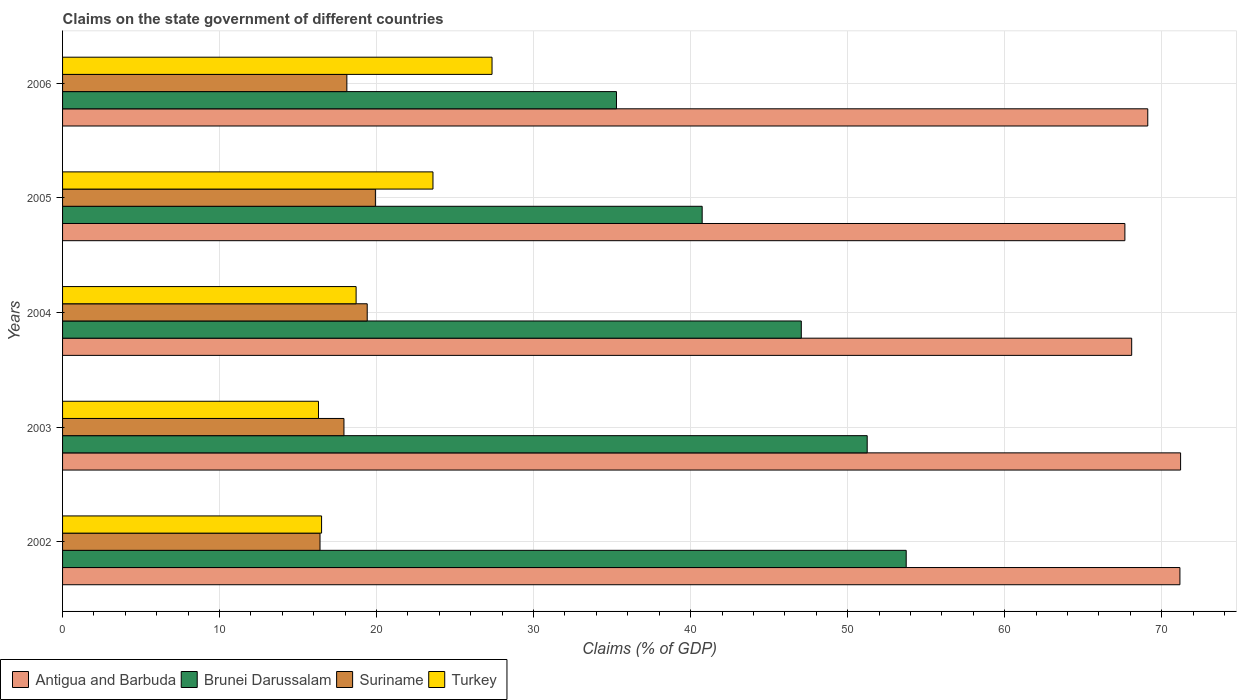How many groups of bars are there?
Make the answer very short. 5. Are the number of bars per tick equal to the number of legend labels?
Ensure brevity in your answer.  Yes. Are the number of bars on each tick of the Y-axis equal?
Offer a terse response. Yes. How many bars are there on the 5th tick from the bottom?
Provide a short and direct response. 4. What is the label of the 2nd group of bars from the top?
Ensure brevity in your answer.  2005. In how many cases, is the number of bars for a given year not equal to the number of legend labels?
Offer a very short reply. 0. What is the percentage of GDP claimed on the state government in Suriname in 2005?
Ensure brevity in your answer.  19.92. Across all years, what is the maximum percentage of GDP claimed on the state government in Antigua and Barbuda?
Keep it short and to the point. 71.21. Across all years, what is the minimum percentage of GDP claimed on the state government in Antigua and Barbuda?
Give a very brief answer. 67.66. In which year was the percentage of GDP claimed on the state government in Suriname minimum?
Your response must be concise. 2002. What is the total percentage of GDP claimed on the state government in Antigua and Barbuda in the graph?
Ensure brevity in your answer.  347.25. What is the difference between the percentage of GDP claimed on the state government in Suriname in 2002 and that in 2005?
Provide a succinct answer. -3.53. What is the difference between the percentage of GDP claimed on the state government in Brunei Darussalam in 2004 and the percentage of GDP claimed on the state government in Antigua and Barbuda in 2006?
Keep it short and to the point. -22.07. What is the average percentage of GDP claimed on the state government in Suriname per year?
Ensure brevity in your answer.  18.35. In the year 2003, what is the difference between the percentage of GDP claimed on the state government in Brunei Darussalam and percentage of GDP claimed on the state government in Suriname?
Give a very brief answer. 33.33. In how many years, is the percentage of GDP claimed on the state government in Suriname greater than 28 %?
Your answer should be compact. 0. What is the ratio of the percentage of GDP claimed on the state government in Turkey in 2003 to that in 2004?
Give a very brief answer. 0.87. Is the percentage of GDP claimed on the state government in Brunei Darussalam in 2004 less than that in 2006?
Offer a very short reply. No. What is the difference between the highest and the second highest percentage of GDP claimed on the state government in Turkey?
Your response must be concise. 3.76. What is the difference between the highest and the lowest percentage of GDP claimed on the state government in Antigua and Barbuda?
Ensure brevity in your answer.  3.55. In how many years, is the percentage of GDP claimed on the state government in Antigua and Barbuda greater than the average percentage of GDP claimed on the state government in Antigua and Barbuda taken over all years?
Your response must be concise. 2. Is it the case that in every year, the sum of the percentage of GDP claimed on the state government in Antigua and Barbuda and percentage of GDP claimed on the state government in Turkey is greater than the sum of percentage of GDP claimed on the state government in Suriname and percentage of GDP claimed on the state government in Brunei Darussalam?
Your answer should be very brief. Yes. What does the 4th bar from the top in 2003 represents?
Provide a short and direct response. Antigua and Barbuda. What does the 1st bar from the bottom in 2005 represents?
Ensure brevity in your answer.  Antigua and Barbuda. Is it the case that in every year, the sum of the percentage of GDP claimed on the state government in Suriname and percentage of GDP claimed on the state government in Brunei Darussalam is greater than the percentage of GDP claimed on the state government in Antigua and Barbuda?
Your response must be concise. No. How many bars are there?
Make the answer very short. 20. Are all the bars in the graph horizontal?
Give a very brief answer. Yes. Are the values on the major ticks of X-axis written in scientific E-notation?
Make the answer very short. No. Does the graph contain any zero values?
Offer a very short reply. No. Does the graph contain grids?
Give a very brief answer. Yes. Where does the legend appear in the graph?
Keep it short and to the point. Bottom left. How many legend labels are there?
Give a very brief answer. 4. What is the title of the graph?
Ensure brevity in your answer.  Claims on the state government of different countries. Does "East Asia (all income levels)" appear as one of the legend labels in the graph?
Make the answer very short. No. What is the label or title of the X-axis?
Your answer should be very brief. Claims (% of GDP). What is the label or title of the Y-axis?
Provide a succinct answer. Years. What is the Claims (% of GDP) of Antigua and Barbuda in 2002?
Your answer should be compact. 71.17. What is the Claims (% of GDP) in Brunei Darussalam in 2002?
Your answer should be compact. 53.73. What is the Claims (% of GDP) in Suriname in 2002?
Offer a very short reply. 16.4. What is the Claims (% of GDP) of Turkey in 2002?
Offer a terse response. 16.5. What is the Claims (% of GDP) in Antigua and Barbuda in 2003?
Offer a terse response. 71.21. What is the Claims (% of GDP) of Brunei Darussalam in 2003?
Give a very brief answer. 51.25. What is the Claims (% of GDP) of Suriname in 2003?
Make the answer very short. 17.92. What is the Claims (% of GDP) in Turkey in 2003?
Give a very brief answer. 16.3. What is the Claims (% of GDP) of Antigua and Barbuda in 2004?
Offer a terse response. 68.09. What is the Claims (% of GDP) of Brunei Darussalam in 2004?
Offer a terse response. 47.05. What is the Claims (% of GDP) of Suriname in 2004?
Offer a very short reply. 19.4. What is the Claims (% of GDP) of Turkey in 2004?
Offer a very short reply. 18.7. What is the Claims (% of GDP) in Antigua and Barbuda in 2005?
Provide a short and direct response. 67.66. What is the Claims (% of GDP) of Brunei Darussalam in 2005?
Keep it short and to the point. 40.74. What is the Claims (% of GDP) of Suriname in 2005?
Ensure brevity in your answer.  19.92. What is the Claims (% of GDP) of Turkey in 2005?
Keep it short and to the point. 23.59. What is the Claims (% of GDP) of Antigua and Barbuda in 2006?
Offer a very short reply. 69.12. What is the Claims (% of GDP) in Brunei Darussalam in 2006?
Keep it short and to the point. 35.28. What is the Claims (% of GDP) in Suriname in 2006?
Provide a succinct answer. 18.11. What is the Claims (% of GDP) of Turkey in 2006?
Give a very brief answer. 27.35. Across all years, what is the maximum Claims (% of GDP) of Antigua and Barbuda?
Ensure brevity in your answer.  71.21. Across all years, what is the maximum Claims (% of GDP) in Brunei Darussalam?
Make the answer very short. 53.73. Across all years, what is the maximum Claims (% of GDP) in Suriname?
Provide a succinct answer. 19.92. Across all years, what is the maximum Claims (% of GDP) in Turkey?
Ensure brevity in your answer.  27.35. Across all years, what is the minimum Claims (% of GDP) in Antigua and Barbuda?
Your answer should be compact. 67.66. Across all years, what is the minimum Claims (% of GDP) of Brunei Darussalam?
Provide a succinct answer. 35.28. Across all years, what is the minimum Claims (% of GDP) in Suriname?
Your answer should be very brief. 16.4. Across all years, what is the minimum Claims (% of GDP) of Turkey?
Your response must be concise. 16.3. What is the total Claims (% of GDP) in Antigua and Barbuda in the graph?
Offer a very short reply. 347.25. What is the total Claims (% of GDP) of Brunei Darussalam in the graph?
Provide a short and direct response. 228.05. What is the total Claims (% of GDP) in Suriname in the graph?
Provide a short and direct response. 91.76. What is the total Claims (% of GDP) in Turkey in the graph?
Keep it short and to the point. 102.44. What is the difference between the Claims (% of GDP) in Antigua and Barbuda in 2002 and that in 2003?
Offer a terse response. -0.04. What is the difference between the Claims (% of GDP) of Brunei Darussalam in 2002 and that in 2003?
Your answer should be very brief. 2.48. What is the difference between the Claims (% of GDP) of Suriname in 2002 and that in 2003?
Offer a terse response. -1.52. What is the difference between the Claims (% of GDP) in Turkey in 2002 and that in 2003?
Your response must be concise. 0.2. What is the difference between the Claims (% of GDP) in Antigua and Barbuda in 2002 and that in 2004?
Keep it short and to the point. 3.07. What is the difference between the Claims (% of GDP) in Brunei Darussalam in 2002 and that in 2004?
Provide a succinct answer. 6.68. What is the difference between the Claims (% of GDP) in Suriname in 2002 and that in 2004?
Offer a very short reply. -3.01. What is the difference between the Claims (% of GDP) in Turkey in 2002 and that in 2004?
Give a very brief answer. -2.2. What is the difference between the Claims (% of GDP) in Antigua and Barbuda in 2002 and that in 2005?
Your answer should be very brief. 3.5. What is the difference between the Claims (% of GDP) of Brunei Darussalam in 2002 and that in 2005?
Give a very brief answer. 13. What is the difference between the Claims (% of GDP) of Suriname in 2002 and that in 2005?
Your answer should be compact. -3.53. What is the difference between the Claims (% of GDP) in Turkey in 2002 and that in 2005?
Offer a terse response. -7.09. What is the difference between the Claims (% of GDP) of Antigua and Barbuda in 2002 and that in 2006?
Make the answer very short. 2.05. What is the difference between the Claims (% of GDP) in Brunei Darussalam in 2002 and that in 2006?
Make the answer very short. 18.45. What is the difference between the Claims (% of GDP) in Suriname in 2002 and that in 2006?
Provide a short and direct response. -1.71. What is the difference between the Claims (% of GDP) of Turkey in 2002 and that in 2006?
Make the answer very short. -10.86. What is the difference between the Claims (% of GDP) in Antigua and Barbuda in 2003 and that in 2004?
Your answer should be very brief. 3.11. What is the difference between the Claims (% of GDP) in Brunei Darussalam in 2003 and that in 2004?
Provide a short and direct response. 4.2. What is the difference between the Claims (% of GDP) in Suriname in 2003 and that in 2004?
Ensure brevity in your answer.  -1.48. What is the difference between the Claims (% of GDP) in Turkey in 2003 and that in 2004?
Provide a short and direct response. -2.4. What is the difference between the Claims (% of GDP) in Antigua and Barbuda in 2003 and that in 2005?
Make the answer very short. 3.55. What is the difference between the Claims (% of GDP) of Brunei Darussalam in 2003 and that in 2005?
Your answer should be compact. 10.51. What is the difference between the Claims (% of GDP) of Suriname in 2003 and that in 2005?
Your response must be concise. -2. What is the difference between the Claims (% of GDP) of Turkey in 2003 and that in 2005?
Provide a short and direct response. -7.29. What is the difference between the Claims (% of GDP) of Antigua and Barbuda in 2003 and that in 2006?
Ensure brevity in your answer.  2.09. What is the difference between the Claims (% of GDP) in Brunei Darussalam in 2003 and that in 2006?
Ensure brevity in your answer.  15.97. What is the difference between the Claims (% of GDP) of Suriname in 2003 and that in 2006?
Provide a succinct answer. -0.19. What is the difference between the Claims (% of GDP) of Turkey in 2003 and that in 2006?
Provide a short and direct response. -11.05. What is the difference between the Claims (% of GDP) in Antigua and Barbuda in 2004 and that in 2005?
Your answer should be compact. 0.43. What is the difference between the Claims (% of GDP) in Brunei Darussalam in 2004 and that in 2005?
Offer a terse response. 6.31. What is the difference between the Claims (% of GDP) in Suriname in 2004 and that in 2005?
Your response must be concise. -0.52. What is the difference between the Claims (% of GDP) of Turkey in 2004 and that in 2005?
Offer a terse response. -4.89. What is the difference between the Claims (% of GDP) in Antigua and Barbuda in 2004 and that in 2006?
Ensure brevity in your answer.  -1.02. What is the difference between the Claims (% of GDP) of Brunei Darussalam in 2004 and that in 2006?
Your answer should be compact. 11.77. What is the difference between the Claims (% of GDP) in Suriname in 2004 and that in 2006?
Offer a very short reply. 1.3. What is the difference between the Claims (% of GDP) of Turkey in 2004 and that in 2006?
Your answer should be very brief. -8.66. What is the difference between the Claims (% of GDP) of Antigua and Barbuda in 2005 and that in 2006?
Offer a terse response. -1.46. What is the difference between the Claims (% of GDP) of Brunei Darussalam in 2005 and that in 2006?
Make the answer very short. 5.46. What is the difference between the Claims (% of GDP) of Suriname in 2005 and that in 2006?
Make the answer very short. 1.82. What is the difference between the Claims (% of GDP) of Turkey in 2005 and that in 2006?
Keep it short and to the point. -3.76. What is the difference between the Claims (% of GDP) of Antigua and Barbuda in 2002 and the Claims (% of GDP) of Brunei Darussalam in 2003?
Ensure brevity in your answer.  19.92. What is the difference between the Claims (% of GDP) of Antigua and Barbuda in 2002 and the Claims (% of GDP) of Suriname in 2003?
Keep it short and to the point. 53.24. What is the difference between the Claims (% of GDP) of Antigua and Barbuda in 2002 and the Claims (% of GDP) of Turkey in 2003?
Offer a terse response. 54.87. What is the difference between the Claims (% of GDP) in Brunei Darussalam in 2002 and the Claims (% of GDP) in Suriname in 2003?
Your response must be concise. 35.81. What is the difference between the Claims (% of GDP) in Brunei Darussalam in 2002 and the Claims (% of GDP) in Turkey in 2003?
Provide a short and direct response. 37.43. What is the difference between the Claims (% of GDP) of Suriname in 2002 and the Claims (% of GDP) of Turkey in 2003?
Offer a terse response. 0.1. What is the difference between the Claims (% of GDP) of Antigua and Barbuda in 2002 and the Claims (% of GDP) of Brunei Darussalam in 2004?
Offer a terse response. 24.11. What is the difference between the Claims (% of GDP) in Antigua and Barbuda in 2002 and the Claims (% of GDP) in Suriname in 2004?
Keep it short and to the point. 51.76. What is the difference between the Claims (% of GDP) of Antigua and Barbuda in 2002 and the Claims (% of GDP) of Turkey in 2004?
Provide a short and direct response. 52.47. What is the difference between the Claims (% of GDP) of Brunei Darussalam in 2002 and the Claims (% of GDP) of Suriname in 2004?
Ensure brevity in your answer.  34.33. What is the difference between the Claims (% of GDP) in Brunei Darussalam in 2002 and the Claims (% of GDP) in Turkey in 2004?
Offer a very short reply. 35.04. What is the difference between the Claims (% of GDP) of Suriname in 2002 and the Claims (% of GDP) of Turkey in 2004?
Your answer should be compact. -2.3. What is the difference between the Claims (% of GDP) of Antigua and Barbuda in 2002 and the Claims (% of GDP) of Brunei Darussalam in 2005?
Provide a succinct answer. 30.43. What is the difference between the Claims (% of GDP) in Antigua and Barbuda in 2002 and the Claims (% of GDP) in Suriname in 2005?
Provide a short and direct response. 51.24. What is the difference between the Claims (% of GDP) of Antigua and Barbuda in 2002 and the Claims (% of GDP) of Turkey in 2005?
Keep it short and to the point. 47.57. What is the difference between the Claims (% of GDP) in Brunei Darussalam in 2002 and the Claims (% of GDP) in Suriname in 2005?
Give a very brief answer. 33.81. What is the difference between the Claims (% of GDP) of Brunei Darussalam in 2002 and the Claims (% of GDP) of Turkey in 2005?
Ensure brevity in your answer.  30.14. What is the difference between the Claims (% of GDP) of Suriname in 2002 and the Claims (% of GDP) of Turkey in 2005?
Make the answer very short. -7.19. What is the difference between the Claims (% of GDP) in Antigua and Barbuda in 2002 and the Claims (% of GDP) in Brunei Darussalam in 2006?
Make the answer very short. 35.89. What is the difference between the Claims (% of GDP) of Antigua and Barbuda in 2002 and the Claims (% of GDP) of Suriname in 2006?
Your answer should be compact. 53.06. What is the difference between the Claims (% of GDP) in Antigua and Barbuda in 2002 and the Claims (% of GDP) in Turkey in 2006?
Keep it short and to the point. 43.81. What is the difference between the Claims (% of GDP) of Brunei Darussalam in 2002 and the Claims (% of GDP) of Suriname in 2006?
Keep it short and to the point. 35.63. What is the difference between the Claims (% of GDP) in Brunei Darussalam in 2002 and the Claims (% of GDP) in Turkey in 2006?
Make the answer very short. 26.38. What is the difference between the Claims (% of GDP) of Suriname in 2002 and the Claims (% of GDP) of Turkey in 2006?
Your answer should be very brief. -10.96. What is the difference between the Claims (% of GDP) in Antigua and Barbuda in 2003 and the Claims (% of GDP) in Brunei Darussalam in 2004?
Ensure brevity in your answer.  24.16. What is the difference between the Claims (% of GDP) in Antigua and Barbuda in 2003 and the Claims (% of GDP) in Suriname in 2004?
Make the answer very short. 51.8. What is the difference between the Claims (% of GDP) in Antigua and Barbuda in 2003 and the Claims (% of GDP) in Turkey in 2004?
Provide a short and direct response. 52.51. What is the difference between the Claims (% of GDP) in Brunei Darussalam in 2003 and the Claims (% of GDP) in Suriname in 2004?
Offer a terse response. 31.84. What is the difference between the Claims (% of GDP) of Brunei Darussalam in 2003 and the Claims (% of GDP) of Turkey in 2004?
Give a very brief answer. 32.55. What is the difference between the Claims (% of GDP) in Suriname in 2003 and the Claims (% of GDP) in Turkey in 2004?
Your response must be concise. -0.77. What is the difference between the Claims (% of GDP) of Antigua and Barbuda in 2003 and the Claims (% of GDP) of Brunei Darussalam in 2005?
Your answer should be very brief. 30.47. What is the difference between the Claims (% of GDP) of Antigua and Barbuda in 2003 and the Claims (% of GDP) of Suriname in 2005?
Keep it short and to the point. 51.28. What is the difference between the Claims (% of GDP) in Antigua and Barbuda in 2003 and the Claims (% of GDP) in Turkey in 2005?
Your response must be concise. 47.62. What is the difference between the Claims (% of GDP) of Brunei Darussalam in 2003 and the Claims (% of GDP) of Suriname in 2005?
Give a very brief answer. 31.32. What is the difference between the Claims (% of GDP) of Brunei Darussalam in 2003 and the Claims (% of GDP) of Turkey in 2005?
Keep it short and to the point. 27.66. What is the difference between the Claims (% of GDP) of Suriname in 2003 and the Claims (% of GDP) of Turkey in 2005?
Provide a succinct answer. -5.67. What is the difference between the Claims (% of GDP) in Antigua and Barbuda in 2003 and the Claims (% of GDP) in Brunei Darussalam in 2006?
Offer a terse response. 35.93. What is the difference between the Claims (% of GDP) in Antigua and Barbuda in 2003 and the Claims (% of GDP) in Suriname in 2006?
Offer a very short reply. 53.1. What is the difference between the Claims (% of GDP) in Antigua and Barbuda in 2003 and the Claims (% of GDP) in Turkey in 2006?
Your answer should be very brief. 43.86. What is the difference between the Claims (% of GDP) of Brunei Darussalam in 2003 and the Claims (% of GDP) of Suriname in 2006?
Your answer should be compact. 33.14. What is the difference between the Claims (% of GDP) of Brunei Darussalam in 2003 and the Claims (% of GDP) of Turkey in 2006?
Keep it short and to the point. 23.9. What is the difference between the Claims (% of GDP) in Suriname in 2003 and the Claims (% of GDP) in Turkey in 2006?
Your response must be concise. -9.43. What is the difference between the Claims (% of GDP) in Antigua and Barbuda in 2004 and the Claims (% of GDP) in Brunei Darussalam in 2005?
Your answer should be very brief. 27.36. What is the difference between the Claims (% of GDP) in Antigua and Barbuda in 2004 and the Claims (% of GDP) in Suriname in 2005?
Make the answer very short. 48.17. What is the difference between the Claims (% of GDP) of Antigua and Barbuda in 2004 and the Claims (% of GDP) of Turkey in 2005?
Make the answer very short. 44.5. What is the difference between the Claims (% of GDP) in Brunei Darussalam in 2004 and the Claims (% of GDP) in Suriname in 2005?
Make the answer very short. 27.13. What is the difference between the Claims (% of GDP) in Brunei Darussalam in 2004 and the Claims (% of GDP) in Turkey in 2005?
Your answer should be compact. 23.46. What is the difference between the Claims (% of GDP) of Suriname in 2004 and the Claims (% of GDP) of Turkey in 2005?
Ensure brevity in your answer.  -4.19. What is the difference between the Claims (% of GDP) in Antigua and Barbuda in 2004 and the Claims (% of GDP) in Brunei Darussalam in 2006?
Keep it short and to the point. 32.82. What is the difference between the Claims (% of GDP) in Antigua and Barbuda in 2004 and the Claims (% of GDP) in Suriname in 2006?
Ensure brevity in your answer.  49.99. What is the difference between the Claims (% of GDP) in Antigua and Barbuda in 2004 and the Claims (% of GDP) in Turkey in 2006?
Offer a very short reply. 40.74. What is the difference between the Claims (% of GDP) in Brunei Darussalam in 2004 and the Claims (% of GDP) in Suriname in 2006?
Give a very brief answer. 28.94. What is the difference between the Claims (% of GDP) in Brunei Darussalam in 2004 and the Claims (% of GDP) in Turkey in 2006?
Your response must be concise. 19.7. What is the difference between the Claims (% of GDP) in Suriname in 2004 and the Claims (% of GDP) in Turkey in 2006?
Make the answer very short. -7.95. What is the difference between the Claims (% of GDP) of Antigua and Barbuda in 2005 and the Claims (% of GDP) of Brunei Darussalam in 2006?
Keep it short and to the point. 32.38. What is the difference between the Claims (% of GDP) of Antigua and Barbuda in 2005 and the Claims (% of GDP) of Suriname in 2006?
Make the answer very short. 49.55. What is the difference between the Claims (% of GDP) in Antigua and Barbuda in 2005 and the Claims (% of GDP) in Turkey in 2006?
Your response must be concise. 40.31. What is the difference between the Claims (% of GDP) of Brunei Darussalam in 2005 and the Claims (% of GDP) of Suriname in 2006?
Provide a succinct answer. 22.63. What is the difference between the Claims (% of GDP) of Brunei Darussalam in 2005 and the Claims (% of GDP) of Turkey in 2006?
Your answer should be compact. 13.38. What is the difference between the Claims (% of GDP) of Suriname in 2005 and the Claims (% of GDP) of Turkey in 2006?
Offer a very short reply. -7.43. What is the average Claims (% of GDP) in Antigua and Barbuda per year?
Keep it short and to the point. 69.45. What is the average Claims (% of GDP) of Brunei Darussalam per year?
Provide a succinct answer. 45.61. What is the average Claims (% of GDP) of Suriname per year?
Provide a succinct answer. 18.35. What is the average Claims (% of GDP) of Turkey per year?
Your response must be concise. 20.49. In the year 2002, what is the difference between the Claims (% of GDP) in Antigua and Barbuda and Claims (% of GDP) in Brunei Darussalam?
Offer a very short reply. 17.43. In the year 2002, what is the difference between the Claims (% of GDP) in Antigua and Barbuda and Claims (% of GDP) in Suriname?
Your answer should be very brief. 54.77. In the year 2002, what is the difference between the Claims (% of GDP) of Antigua and Barbuda and Claims (% of GDP) of Turkey?
Make the answer very short. 54.67. In the year 2002, what is the difference between the Claims (% of GDP) of Brunei Darussalam and Claims (% of GDP) of Suriname?
Keep it short and to the point. 37.34. In the year 2002, what is the difference between the Claims (% of GDP) in Brunei Darussalam and Claims (% of GDP) in Turkey?
Make the answer very short. 37.24. In the year 2002, what is the difference between the Claims (% of GDP) in Suriname and Claims (% of GDP) in Turkey?
Your answer should be very brief. -0.1. In the year 2003, what is the difference between the Claims (% of GDP) in Antigua and Barbuda and Claims (% of GDP) in Brunei Darussalam?
Your answer should be compact. 19.96. In the year 2003, what is the difference between the Claims (% of GDP) in Antigua and Barbuda and Claims (% of GDP) in Suriname?
Your response must be concise. 53.29. In the year 2003, what is the difference between the Claims (% of GDP) in Antigua and Barbuda and Claims (% of GDP) in Turkey?
Ensure brevity in your answer.  54.91. In the year 2003, what is the difference between the Claims (% of GDP) of Brunei Darussalam and Claims (% of GDP) of Suriname?
Provide a short and direct response. 33.33. In the year 2003, what is the difference between the Claims (% of GDP) in Brunei Darussalam and Claims (% of GDP) in Turkey?
Make the answer very short. 34.95. In the year 2003, what is the difference between the Claims (% of GDP) of Suriname and Claims (% of GDP) of Turkey?
Keep it short and to the point. 1.62. In the year 2004, what is the difference between the Claims (% of GDP) in Antigua and Barbuda and Claims (% of GDP) in Brunei Darussalam?
Make the answer very short. 21.04. In the year 2004, what is the difference between the Claims (% of GDP) in Antigua and Barbuda and Claims (% of GDP) in Suriname?
Provide a succinct answer. 48.69. In the year 2004, what is the difference between the Claims (% of GDP) in Antigua and Barbuda and Claims (% of GDP) in Turkey?
Your answer should be compact. 49.4. In the year 2004, what is the difference between the Claims (% of GDP) in Brunei Darussalam and Claims (% of GDP) in Suriname?
Keep it short and to the point. 27.65. In the year 2004, what is the difference between the Claims (% of GDP) in Brunei Darussalam and Claims (% of GDP) in Turkey?
Make the answer very short. 28.36. In the year 2004, what is the difference between the Claims (% of GDP) of Suriname and Claims (% of GDP) of Turkey?
Make the answer very short. 0.71. In the year 2005, what is the difference between the Claims (% of GDP) of Antigua and Barbuda and Claims (% of GDP) of Brunei Darussalam?
Your answer should be compact. 26.92. In the year 2005, what is the difference between the Claims (% of GDP) of Antigua and Barbuda and Claims (% of GDP) of Suriname?
Offer a terse response. 47.74. In the year 2005, what is the difference between the Claims (% of GDP) in Antigua and Barbuda and Claims (% of GDP) in Turkey?
Your answer should be compact. 44.07. In the year 2005, what is the difference between the Claims (% of GDP) of Brunei Darussalam and Claims (% of GDP) of Suriname?
Offer a terse response. 20.81. In the year 2005, what is the difference between the Claims (% of GDP) of Brunei Darussalam and Claims (% of GDP) of Turkey?
Your response must be concise. 17.15. In the year 2005, what is the difference between the Claims (% of GDP) in Suriname and Claims (% of GDP) in Turkey?
Provide a short and direct response. -3.67. In the year 2006, what is the difference between the Claims (% of GDP) in Antigua and Barbuda and Claims (% of GDP) in Brunei Darussalam?
Make the answer very short. 33.84. In the year 2006, what is the difference between the Claims (% of GDP) in Antigua and Barbuda and Claims (% of GDP) in Suriname?
Your answer should be compact. 51.01. In the year 2006, what is the difference between the Claims (% of GDP) of Antigua and Barbuda and Claims (% of GDP) of Turkey?
Keep it short and to the point. 41.76. In the year 2006, what is the difference between the Claims (% of GDP) of Brunei Darussalam and Claims (% of GDP) of Suriname?
Your answer should be very brief. 17.17. In the year 2006, what is the difference between the Claims (% of GDP) of Brunei Darussalam and Claims (% of GDP) of Turkey?
Make the answer very short. 7.93. In the year 2006, what is the difference between the Claims (% of GDP) in Suriname and Claims (% of GDP) in Turkey?
Make the answer very short. -9.25. What is the ratio of the Claims (% of GDP) of Antigua and Barbuda in 2002 to that in 2003?
Your answer should be very brief. 1. What is the ratio of the Claims (% of GDP) in Brunei Darussalam in 2002 to that in 2003?
Your response must be concise. 1.05. What is the ratio of the Claims (% of GDP) of Suriname in 2002 to that in 2003?
Your answer should be very brief. 0.91. What is the ratio of the Claims (% of GDP) in Turkey in 2002 to that in 2003?
Your response must be concise. 1.01. What is the ratio of the Claims (% of GDP) of Antigua and Barbuda in 2002 to that in 2004?
Offer a terse response. 1.05. What is the ratio of the Claims (% of GDP) in Brunei Darussalam in 2002 to that in 2004?
Offer a terse response. 1.14. What is the ratio of the Claims (% of GDP) in Suriname in 2002 to that in 2004?
Offer a terse response. 0.85. What is the ratio of the Claims (% of GDP) of Turkey in 2002 to that in 2004?
Your answer should be compact. 0.88. What is the ratio of the Claims (% of GDP) in Antigua and Barbuda in 2002 to that in 2005?
Make the answer very short. 1.05. What is the ratio of the Claims (% of GDP) of Brunei Darussalam in 2002 to that in 2005?
Your answer should be compact. 1.32. What is the ratio of the Claims (% of GDP) in Suriname in 2002 to that in 2005?
Your response must be concise. 0.82. What is the ratio of the Claims (% of GDP) of Turkey in 2002 to that in 2005?
Your answer should be compact. 0.7. What is the ratio of the Claims (% of GDP) in Antigua and Barbuda in 2002 to that in 2006?
Make the answer very short. 1.03. What is the ratio of the Claims (% of GDP) of Brunei Darussalam in 2002 to that in 2006?
Ensure brevity in your answer.  1.52. What is the ratio of the Claims (% of GDP) in Suriname in 2002 to that in 2006?
Your response must be concise. 0.91. What is the ratio of the Claims (% of GDP) of Turkey in 2002 to that in 2006?
Give a very brief answer. 0.6. What is the ratio of the Claims (% of GDP) in Antigua and Barbuda in 2003 to that in 2004?
Your answer should be very brief. 1.05. What is the ratio of the Claims (% of GDP) in Brunei Darussalam in 2003 to that in 2004?
Provide a short and direct response. 1.09. What is the ratio of the Claims (% of GDP) in Suriname in 2003 to that in 2004?
Give a very brief answer. 0.92. What is the ratio of the Claims (% of GDP) in Turkey in 2003 to that in 2004?
Give a very brief answer. 0.87. What is the ratio of the Claims (% of GDP) of Antigua and Barbuda in 2003 to that in 2005?
Keep it short and to the point. 1.05. What is the ratio of the Claims (% of GDP) of Brunei Darussalam in 2003 to that in 2005?
Keep it short and to the point. 1.26. What is the ratio of the Claims (% of GDP) of Suriname in 2003 to that in 2005?
Keep it short and to the point. 0.9. What is the ratio of the Claims (% of GDP) of Turkey in 2003 to that in 2005?
Ensure brevity in your answer.  0.69. What is the ratio of the Claims (% of GDP) of Antigua and Barbuda in 2003 to that in 2006?
Provide a succinct answer. 1.03. What is the ratio of the Claims (% of GDP) of Brunei Darussalam in 2003 to that in 2006?
Give a very brief answer. 1.45. What is the ratio of the Claims (% of GDP) in Suriname in 2003 to that in 2006?
Your response must be concise. 0.99. What is the ratio of the Claims (% of GDP) of Turkey in 2003 to that in 2006?
Provide a succinct answer. 0.6. What is the ratio of the Claims (% of GDP) of Antigua and Barbuda in 2004 to that in 2005?
Your response must be concise. 1.01. What is the ratio of the Claims (% of GDP) of Brunei Darussalam in 2004 to that in 2005?
Your response must be concise. 1.16. What is the ratio of the Claims (% of GDP) of Suriname in 2004 to that in 2005?
Your response must be concise. 0.97. What is the ratio of the Claims (% of GDP) in Turkey in 2004 to that in 2005?
Provide a short and direct response. 0.79. What is the ratio of the Claims (% of GDP) of Antigua and Barbuda in 2004 to that in 2006?
Provide a succinct answer. 0.99. What is the ratio of the Claims (% of GDP) of Brunei Darussalam in 2004 to that in 2006?
Provide a short and direct response. 1.33. What is the ratio of the Claims (% of GDP) in Suriname in 2004 to that in 2006?
Ensure brevity in your answer.  1.07. What is the ratio of the Claims (% of GDP) in Turkey in 2004 to that in 2006?
Offer a terse response. 0.68. What is the ratio of the Claims (% of GDP) in Antigua and Barbuda in 2005 to that in 2006?
Offer a terse response. 0.98. What is the ratio of the Claims (% of GDP) of Brunei Darussalam in 2005 to that in 2006?
Your response must be concise. 1.15. What is the ratio of the Claims (% of GDP) in Suriname in 2005 to that in 2006?
Give a very brief answer. 1.1. What is the ratio of the Claims (% of GDP) of Turkey in 2005 to that in 2006?
Provide a short and direct response. 0.86. What is the difference between the highest and the second highest Claims (% of GDP) in Antigua and Barbuda?
Your answer should be compact. 0.04. What is the difference between the highest and the second highest Claims (% of GDP) of Brunei Darussalam?
Offer a very short reply. 2.48. What is the difference between the highest and the second highest Claims (% of GDP) in Suriname?
Offer a terse response. 0.52. What is the difference between the highest and the second highest Claims (% of GDP) in Turkey?
Offer a terse response. 3.76. What is the difference between the highest and the lowest Claims (% of GDP) of Antigua and Barbuda?
Offer a very short reply. 3.55. What is the difference between the highest and the lowest Claims (% of GDP) of Brunei Darussalam?
Provide a short and direct response. 18.45. What is the difference between the highest and the lowest Claims (% of GDP) of Suriname?
Keep it short and to the point. 3.53. What is the difference between the highest and the lowest Claims (% of GDP) in Turkey?
Your answer should be compact. 11.05. 